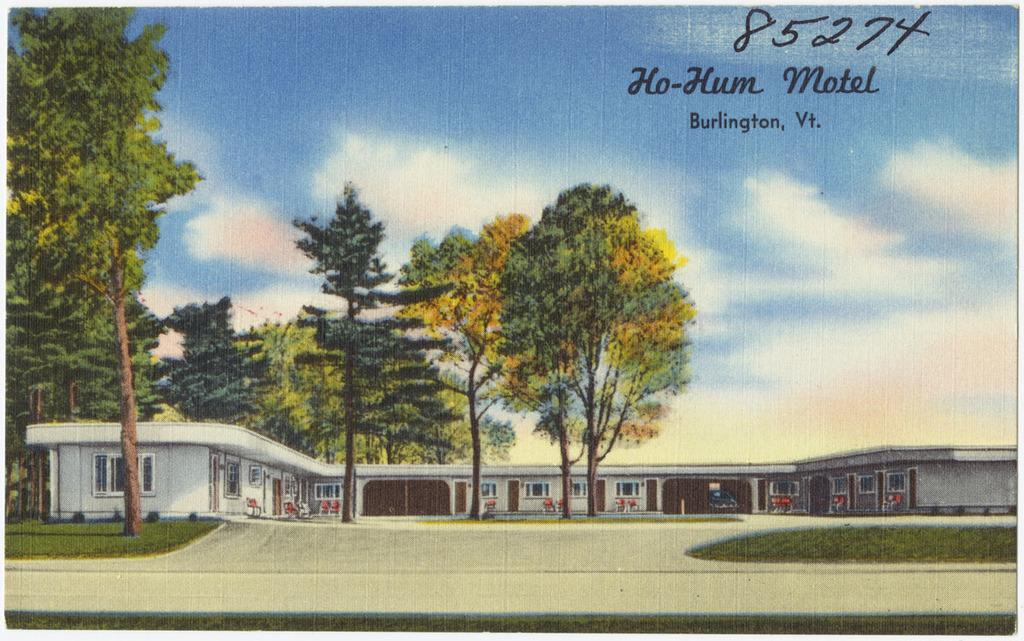<image>
Render a clear and concise summary of the photo. A postcard of the Ho-Hum Motel in Burlington, Vermont. 